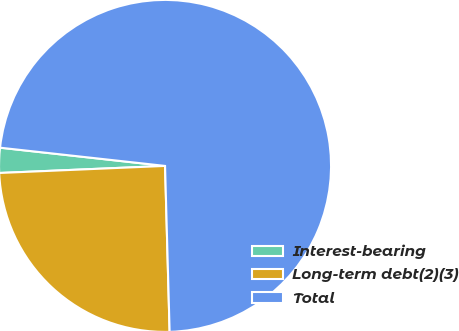Convert chart to OTSL. <chart><loc_0><loc_0><loc_500><loc_500><pie_chart><fcel>Interest-bearing<fcel>Long-term debt(2)(3)<fcel>Total<nl><fcel>2.43%<fcel>24.76%<fcel>72.81%<nl></chart> 